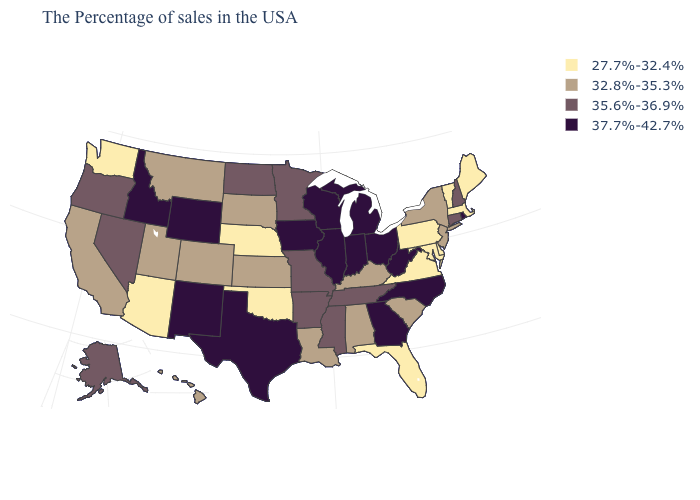Does the first symbol in the legend represent the smallest category?
Keep it brief. Yes. What is the value of Delaware?
Keep it brief. 27.7%-32.4%. Which states hav the highest value in the Northeast?
Be succinct. Rhode Island. Name the states that have a value in the range 32.8%-35.3%?
Concise answer only. New York, New Jersey, South Carolina, Kentucky, Alabama, Louisiana, Kansas, South Dakota, Colorado, Utah, Montana, California, Hawaii. What is the value of Kentucky?
Short answer required. 32.8%-35.3%. Among the states that border Iowa , does Nebraska have the lowest value?
Answer briefly. Yes. Which states have the lowest value in the MidWest?
Concise answer only. Nebraska. Does the map have missing data?
Concise answer only. No. What is the highest value in the West ?
Answer briefly. 37.7%-42.7%. Name the states that have a value in the range 37.7%-42.7%?
Write a very short answer. Rhode Island, North Carolina, West Virginia, Ohio, Georgia, Michigan, Indiana, Wisconsin, Illinois, Iowa, Texas, Wyoming, New Mexico, Idaho. Does the first symbol in the legend represent the smallest category?
Give a very brief answer. Yes. Does the first symbol in the legend represent the smallest category?
Quick response, please. Yes. Does Nevada have the same value as Louisiana?
Write a very short answer. No. Does New Hampshire have the highest value in the Northeast?
Be succinct. No. Does Georgia have a higher value than Florida?
Quick response, please. Yes. 